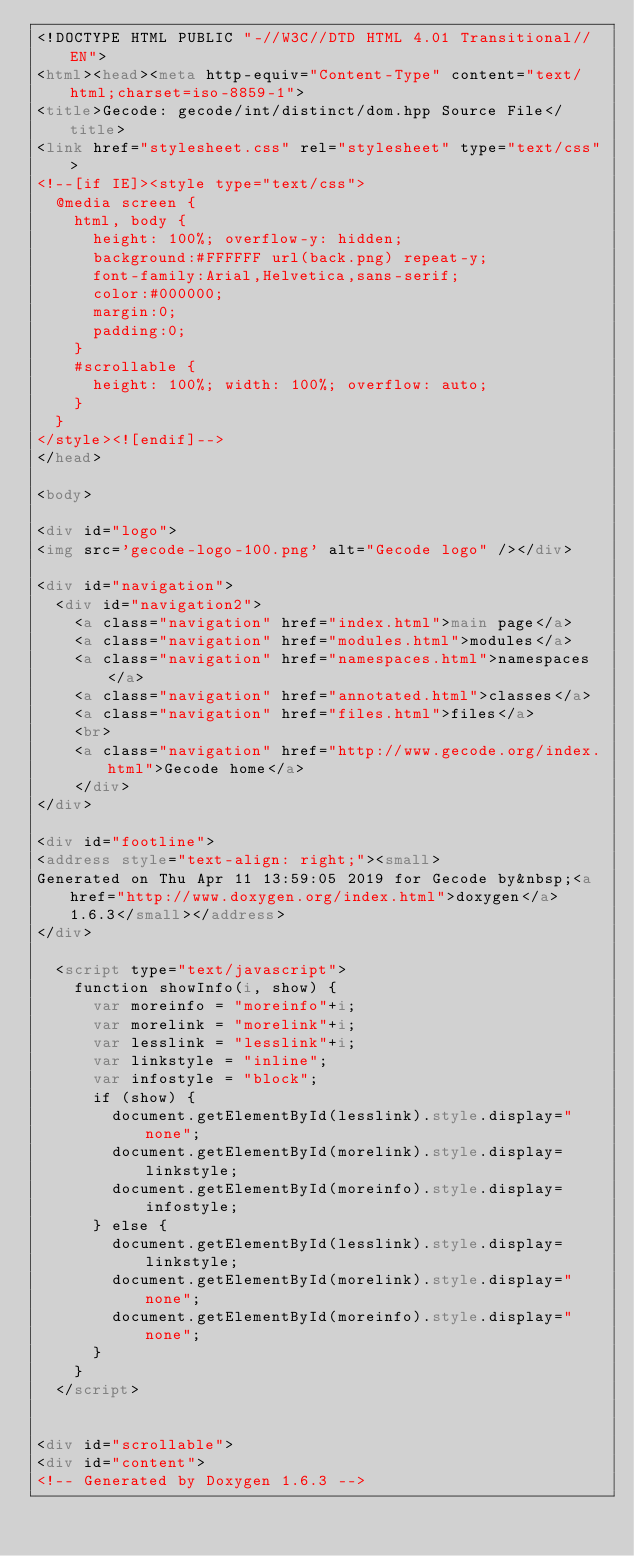<code> <loc_0><loc_0><loc_500><loc_500><_HTML_><!DOCTYPE HTML PUBLIC "-//W3C//DTD HTML 4.01 Transitional//EN">
<html><head><meta http-equiv="Content-Type" content="text/html;charset=iso-8859-1">
<title>Gecode: gecode/int/distinct/dom.hpp Source File</title>
<link href="stylesheet.css" rel="stylesheet" type="text/css">
<!--[if IE]><style type="text/css">
  @media screen {
    html, body {
      height: 100%; overflow-y: hidden;
      background:#FFFFFF url(back.png) repeat-y;
      font-family:Arial,Helvetica,sans-serif;
      color:#000000;
      margin:0;
      padding:0;
    }
    #scrollable {
      height: 100%; width: 100%; overflow: auto;
    }
  }
</style><![endif]-->
</head>

<body>

<div id="logo">
<img src='gecode-logo-100.png' alt="Gecode logo" /></div>

<div id="navigation">
  <div id="navigation2">
    <a class="navigation" href="index.html">main page</a>
    <a class="navigation" href="modules.html">modules</a>
    <a class="navigation" href="namespaces.html">namespaces</a>
    <a class="navigation" href="annotated.html">classes</a>
    <a class="navigation" href="files.html">files</a>
    <br>
    <a class="navigation" href="http://www.gecode.org/index.html">Gecode home</a>
    </div>
</div>

<div id="footline">
<address style="text-align: right;"><small>
Generated on Thu Apr 11 13:59:05 2019 for Gecode by&nbsp;<a href="http://www.doxygen.org/index.html">doxygen</a> 1.6.3</small></address>
</div>

  <script type="text/javascript">
    function showInfo(i, show) {
      var moreinfo = "moreinfo"+i;
      var morelink = "morelink"+i;
      var lesslink = "lesslink"+i;
      var linkstyle = "inline";
      var infostyle = "block";
      if (show) {
        document.getElementById(lesslink).style.display="none";
        document.getElementById(morelink).style.display=linkstyle;
        document.getElementById(moreinfo).style.display=infostyle;
      } else {
        document.getElementById(lesslink).style.display=linkstyle;
        document.getElementById(morelink).style.display="none";
        document.getElementById(moreinfo).style.display="none";
      }
    }
  </script>


<div id="scrollable">
<div id="content">
<!-- Generated by Doxygen 1.6.3 --></code> 